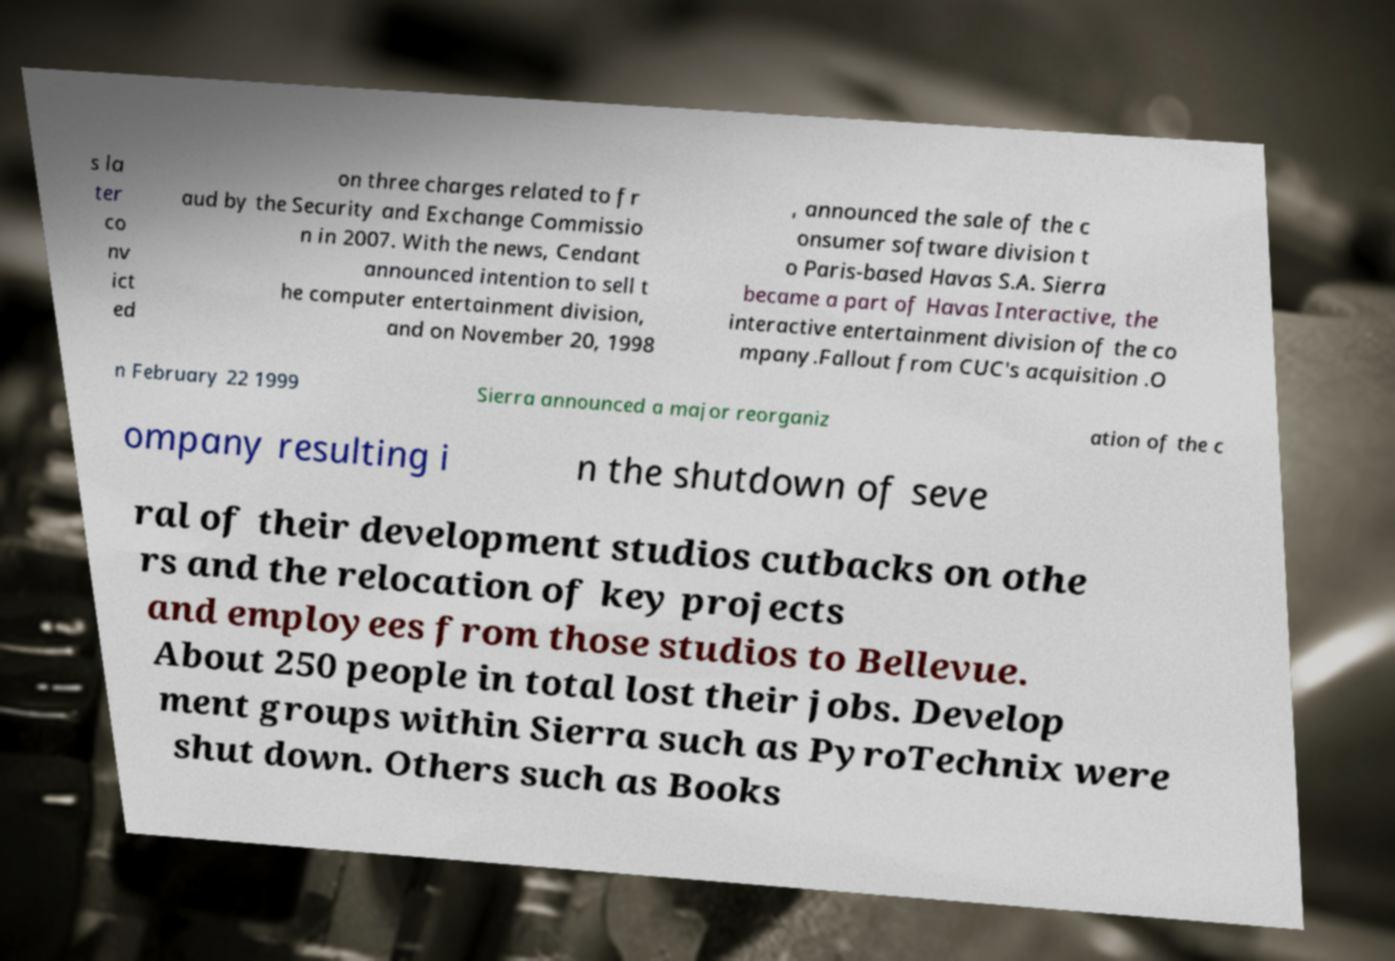There's text embedded in this image that I need extracted. Can you transcribe it verbatim? s la ter co nv ict ed on three charges related to fr aud by the Security and Exchange Commissio n in 2007. With the news, Cendant announced intention to sell t he computer entertainment division, and on November 20, 1998 , announced the sale of the c onsumer software division t o Paris-based Havas S.A. Sierra became a part of Havas Interactive, the interactive entertainment division of the co mpany.Fallout from CUC's acquisition .O n February 22 1999 Sierra announced a major reorganiz ation of the c ompany resulting i n the shutdown of seve ral of their development studios cutbacks on othe rs and the relocation of key projects and employees from those studios to Bellevue. About 250 people in total lost their jobs. Develop ment groups within Sierra such as PyroTechnix were shut down. Others such as Books 